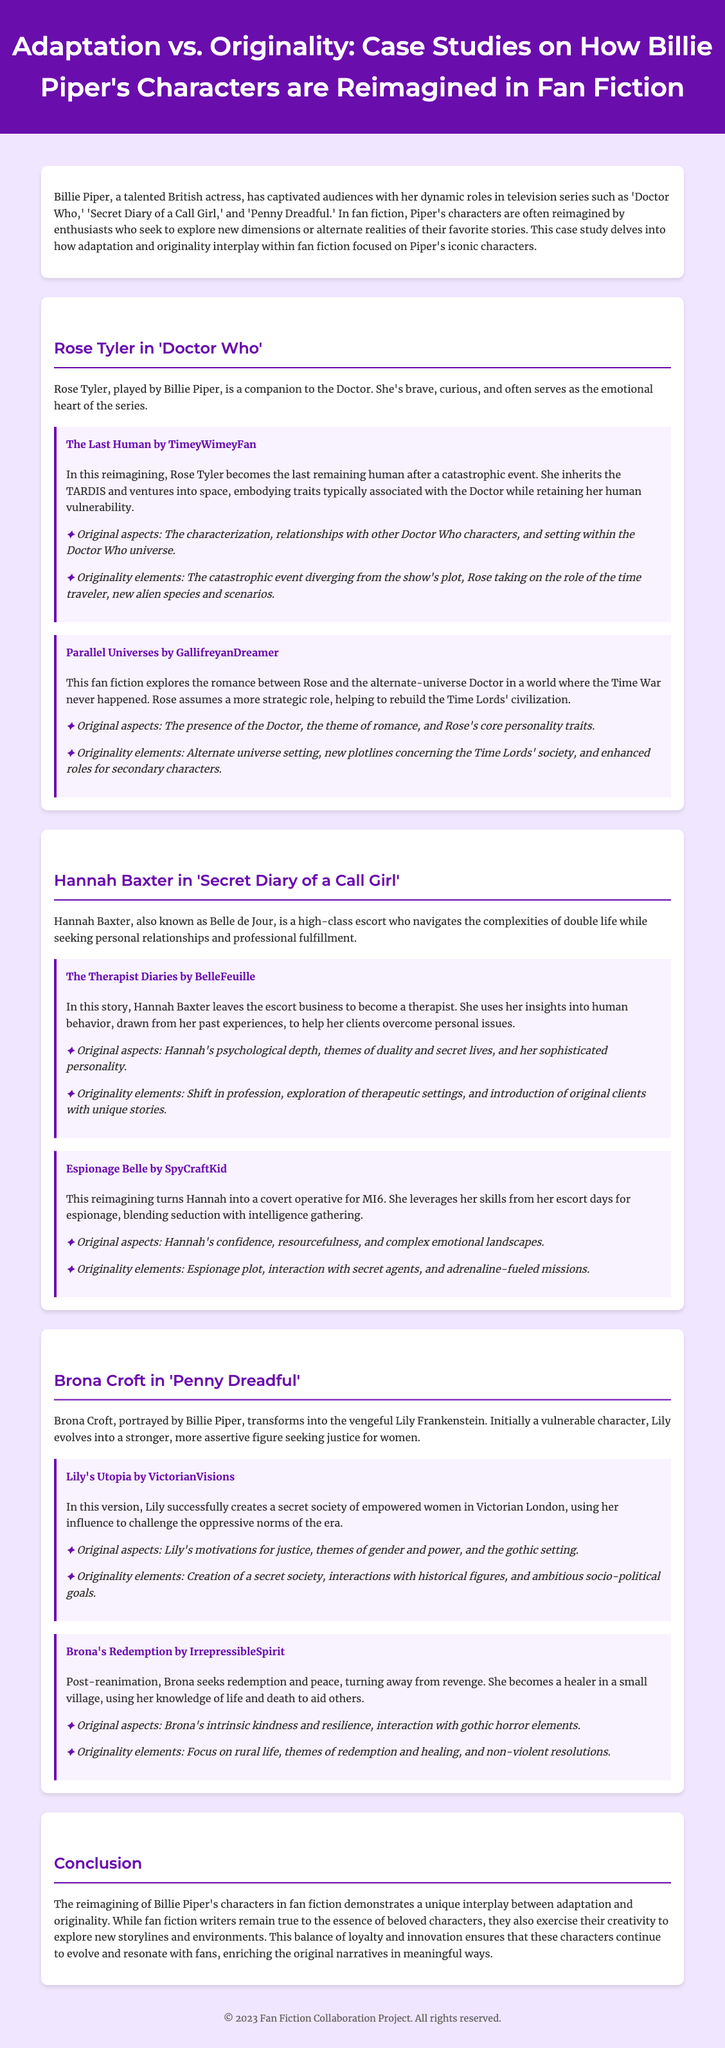What role does Rose Tyler play in 'Doctor Who'? Rose Tyler is a companion to the Doctor.
Answer: Companion Who wrote "The Last Human"? The fan fiction "The Last Human" was written by TimeyWimeyFan.
Answer: TimeyWimeyFan What transformation occurs for Hannah Baxter in "The Therapist Diaries"? Hannah Baxter leaves the escort business to become a therapist.
Answer: Becomes a therapist Which character evolves into Lilly Frankenstein in 'Penny Dreadful'? Brona Croft transforms into the vengeful Lily Frankenstein.
Answer: Brona Croft What is a key element of originality in "Lily's Utopia"? The creation of a secret society of empowered women.
Answer: Secret society In what setting does "Parallel Universes" explore a romance? A world where the Time War never happened.
Answer: Alternate universe What do fan fiction writers aim to explore with Piper's characters? They seek to explore new dimensions or alternate realities.
Answer: New dimensions Which common theme is present in both "The Therapist Diaries" and "Espionage Belle"? Both stories explore aspects of Hannah's character and her capabilities.
Answer: Character capability How does the document categorize its main sections? It categorizes them into case studies focused on different characters.
Answer: Case studies 